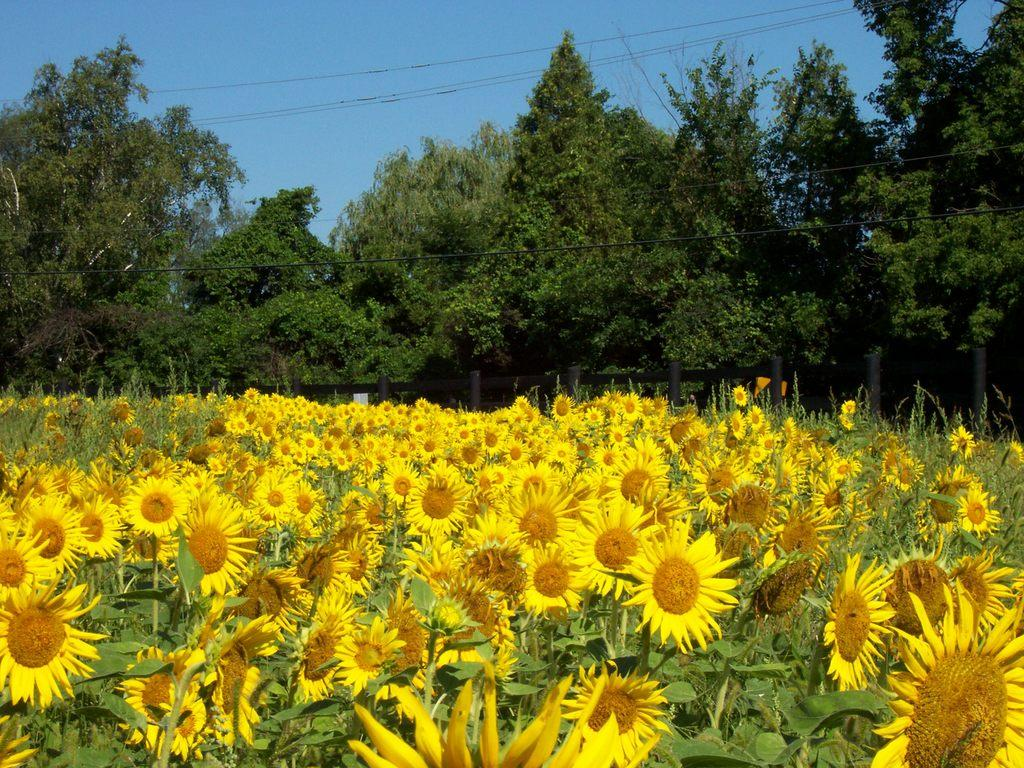What type of plants can be seen in the image? There is a crop of sunflowers in the image. What other natural elements are present in the image? There are trees in the image. Are there any man-made structures visible in the image? Yes, electric wires are present in the image. What is visible at the top of the image? The sky is visible at the top of the image. How many feet are visible in the image? There are no feet present in the image. What type of book can be seen on the sunflower in the image? There is no book present in the image; it features a crop of sunflowers and trees. 